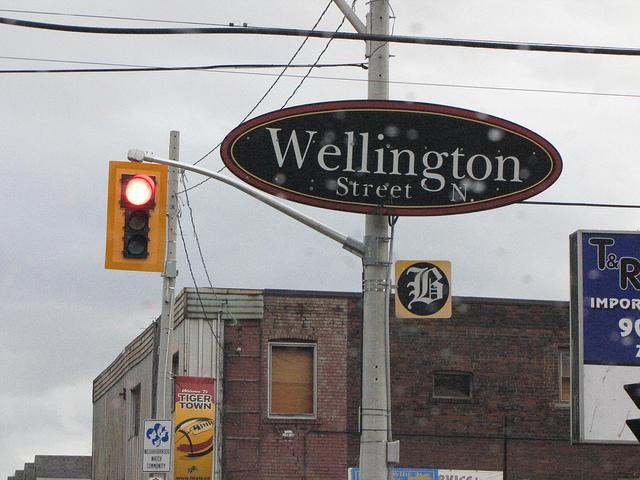What street is this?
Give a very brief answer. Wellington. What is the name of the local football team?
Answer briefly. Tigers. How many signs are there?
Give a very brief answer. 5. 